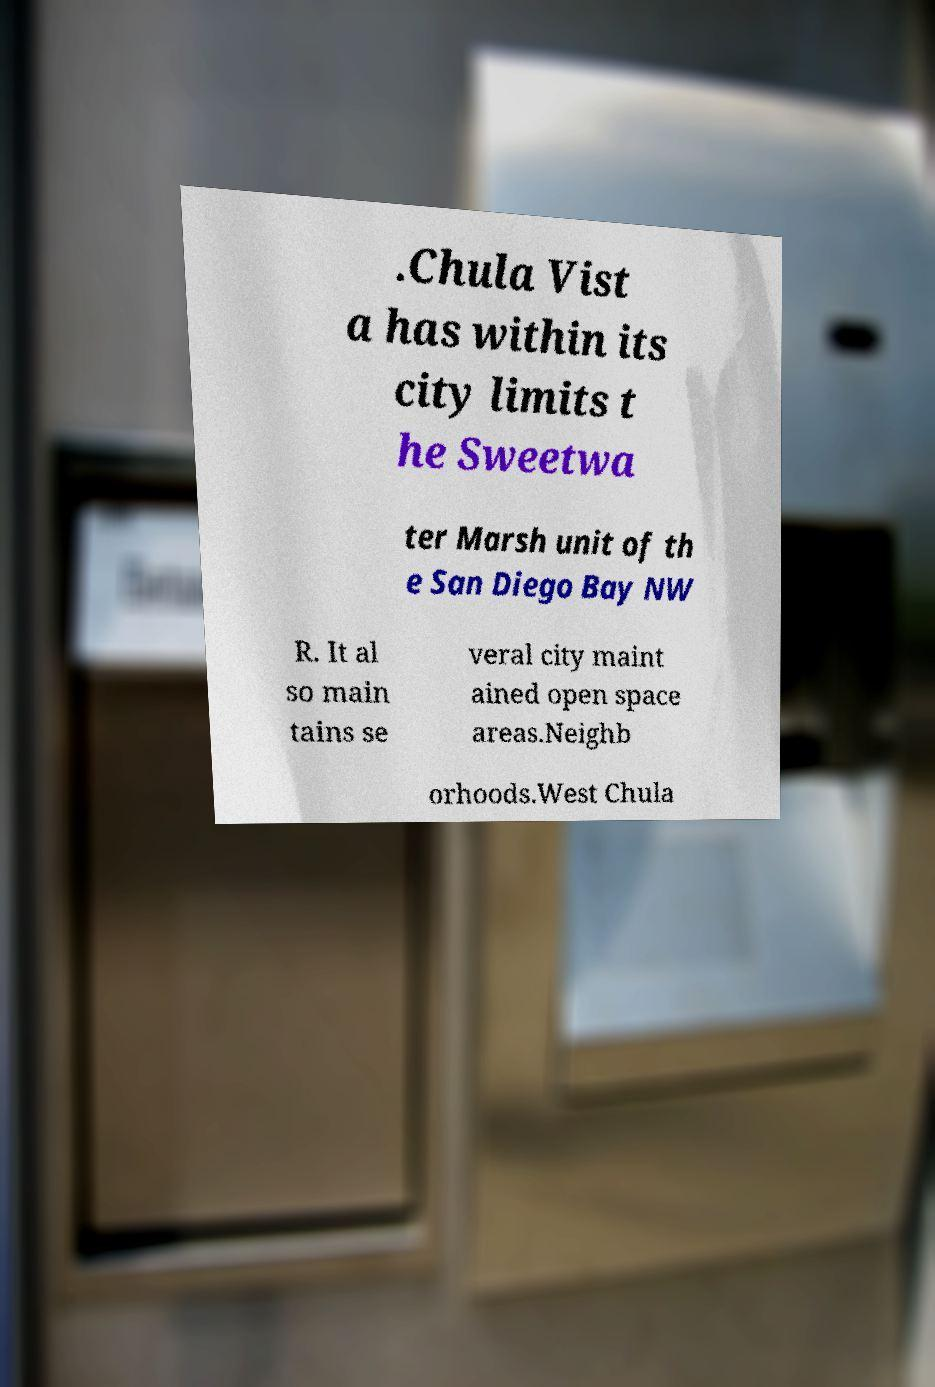There's text embedded in this image that I need extracted. Can you transcribe it verbatim? .Chula Vist a has within its city limits t he Sweetwa ter Marsh unit of th e San Diego Bay NW R. It al so main tains se veral city maint ained open space areas.Neighb orhoods.West Chula 